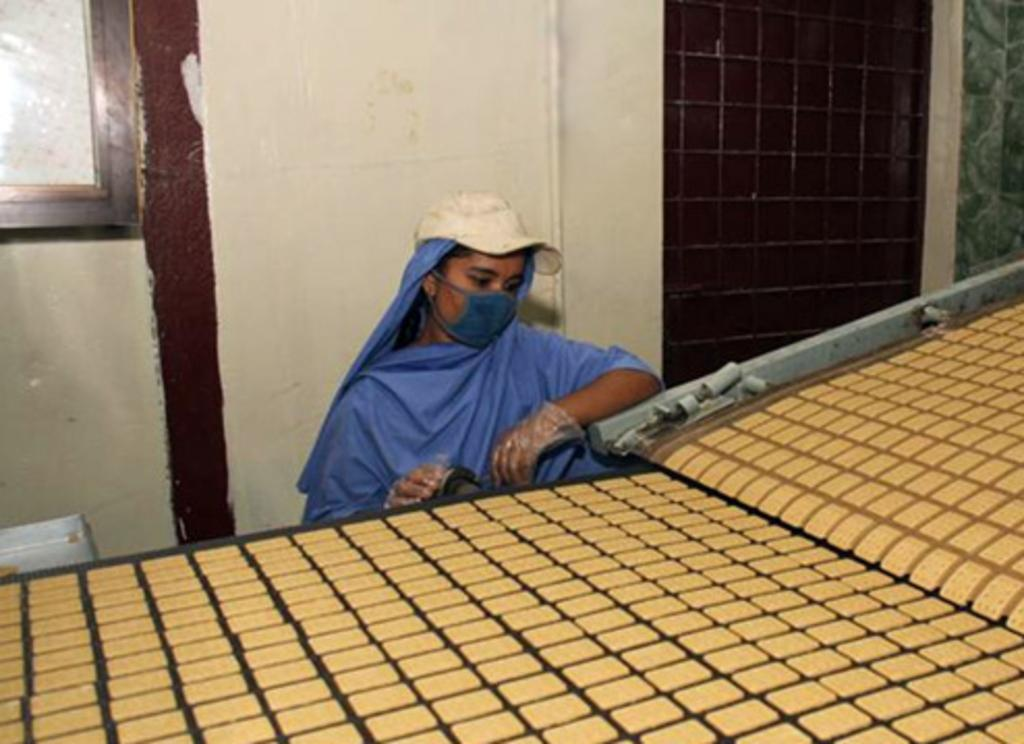Who is present in the image? There is a woman in the image. What is the woman wearing on her head? The woman is wearing a cap. What other protective gear is the woman wearing? The woman is wearing gloves and a mask. What is the woman doing in the image? The woman is behind a machine. What is on the machine? There is food on the machine. What is attached to the wall in the image? There is a frame attached to the wall. What architectural feature is present in the wall? A: There is a window in the wall. What type of cakes is the carpenter making in the image? There is no carpenter or cakes present in the image. What things can be seen in the image? This question is too vague and cannot be answered definitively based on the provided facts. Instead, we can ask specific questions about the objects and subjects in the image, such as the woman, her clothing, the machine, and the wall features. 